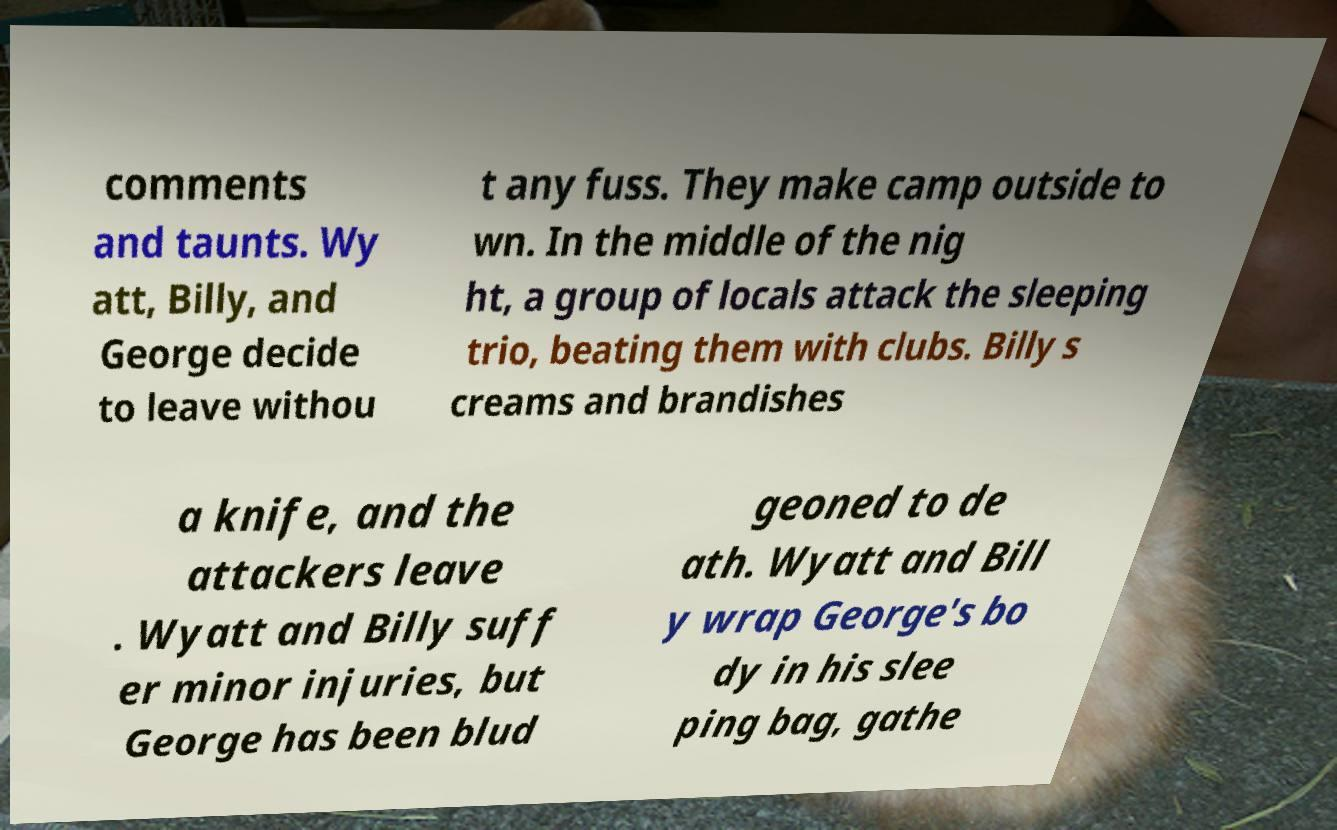Can you accurately transcribe the text from the provided image for me? comments and taunts. Wy att, Billy, and George decide to leave withou t any fuss. They make camp outside to wn. In the middle of the nig ht, a group of locals attack the sleeping trio, beating them with clubs. Billy s creams and brandishes a knife, and the attackers leave . Wyatt and Billy suff er minor injuries, but George has been blud geoned to de ath. Wyatt and Bill y wrap George's bo dy in his slee ping bag, gathe 